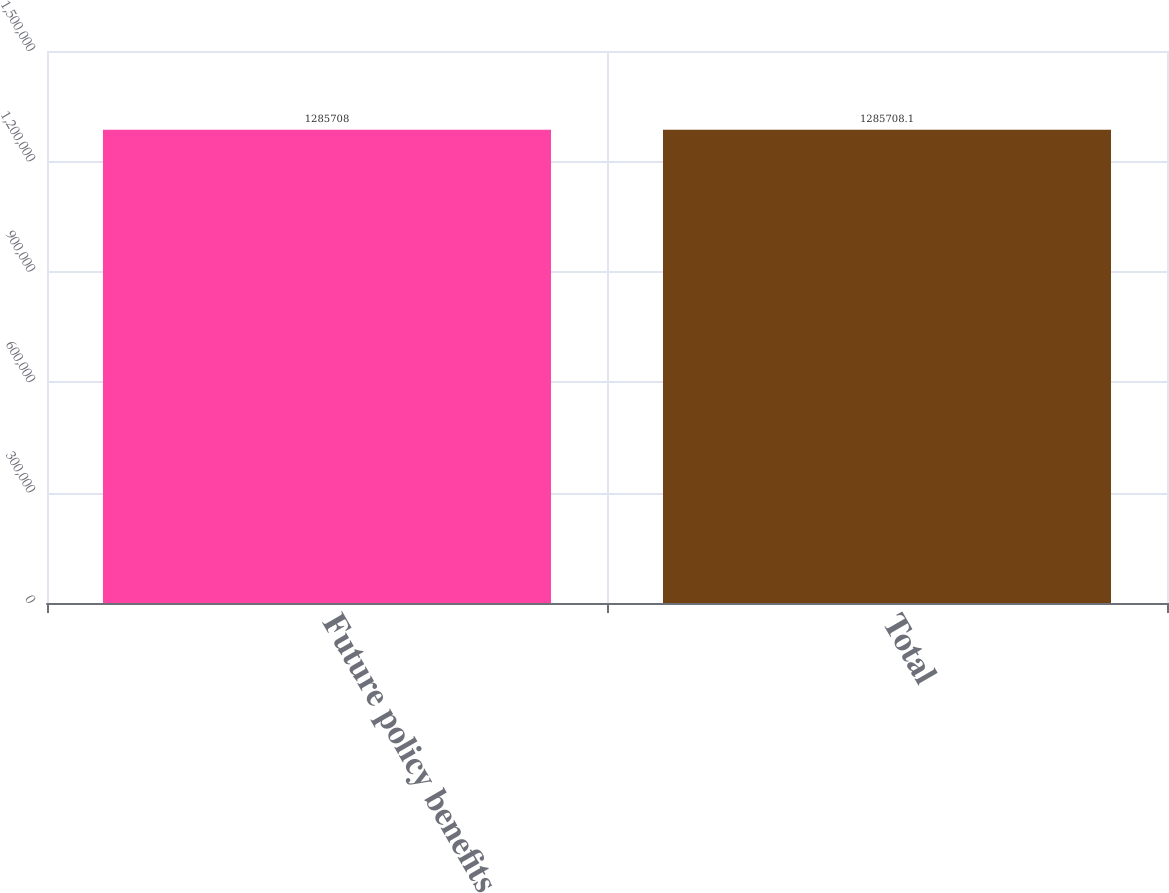Convert chart to OTSL. <chart><loc_0><loc_0><loc_500><loc_500><bar_chart><fcel>Future policy benefits<fcel>Total<nl><fcel>1.28571e+06<fcel>1.28571e+06<nl></chart> 